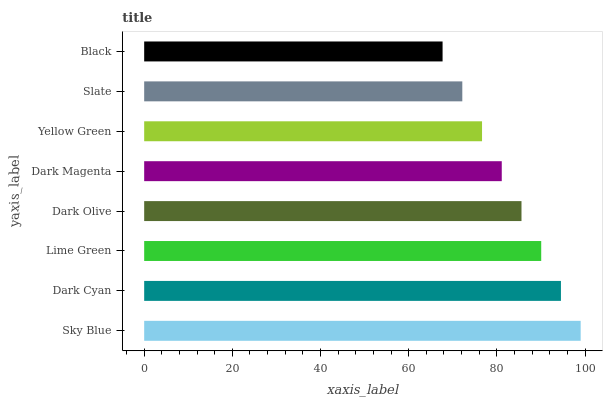Is Black the minimum?
Answer yes or no. Yes. Is Sky Blue the maximum?
Answer yes or no. Yes. Is Dark Cyan the minimum?
Answer yes or no. No. Is Dark Cyan the maximum?
Answer yes or no. No. Is Sky Blue greater than Dark Cyan?
Answer yes or no. Yes. Is Dark Cyan less than Sky Blue?
Answer yes or no. Yes. Is Dark Cyan greater than Sky Blue?
Answer yes or no. No. Is Sky Blue less than Dark Cyan?
Answer yes or no. No. Is Dark Olive the high median?
Answer yes or no. Yes. Is Dark Magenta the low median?
Answer yes or no. Yes. Is Dark Cyan the high median?
Answer yes or no. No. Is Yellow Green the low median?
Answer yes or no. No. 